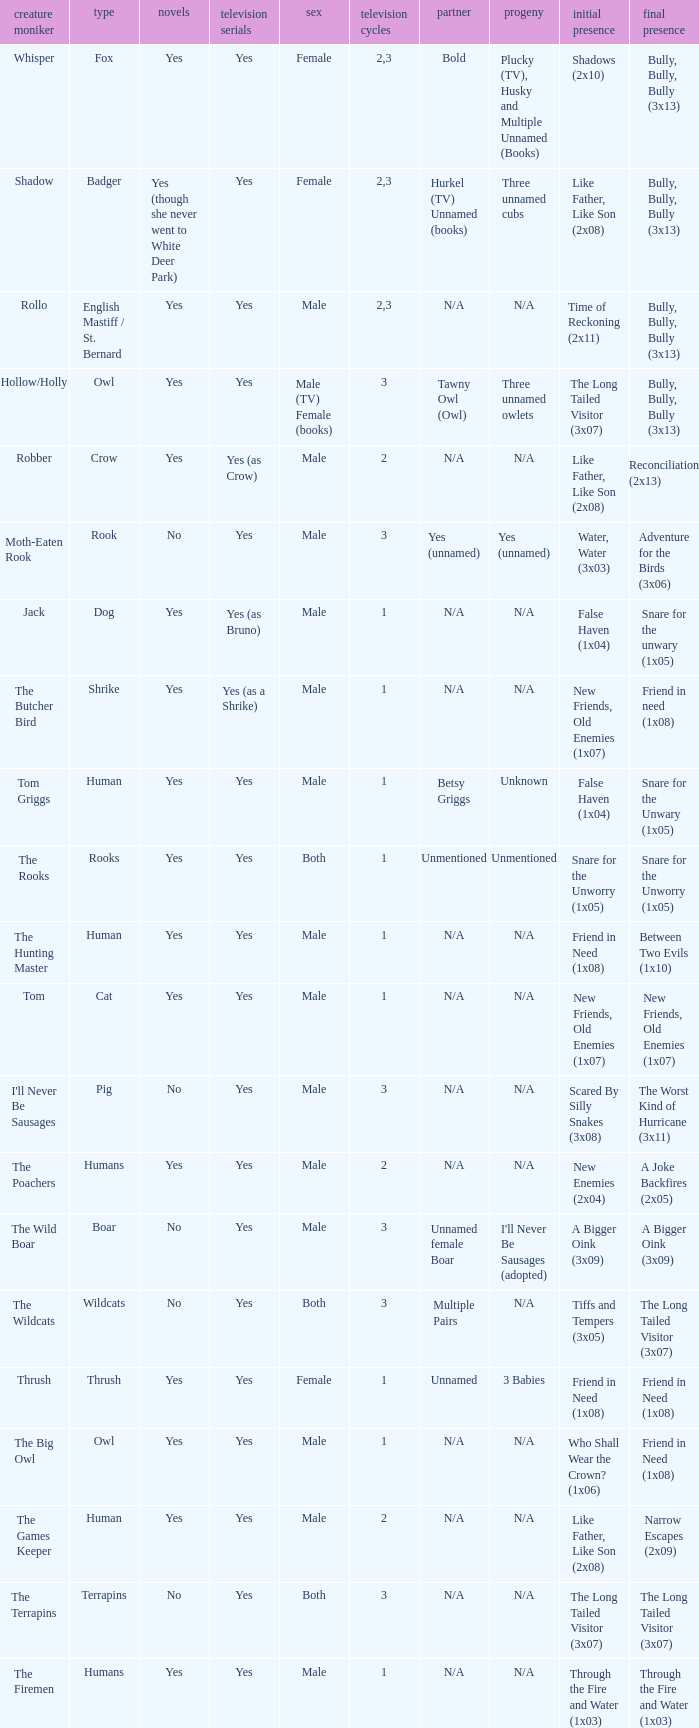What is the mate for Last Appearance of bully, bully, bully (3x13) for the animal named hollow/holly later than season 1? Tawny Owl (Owl). 